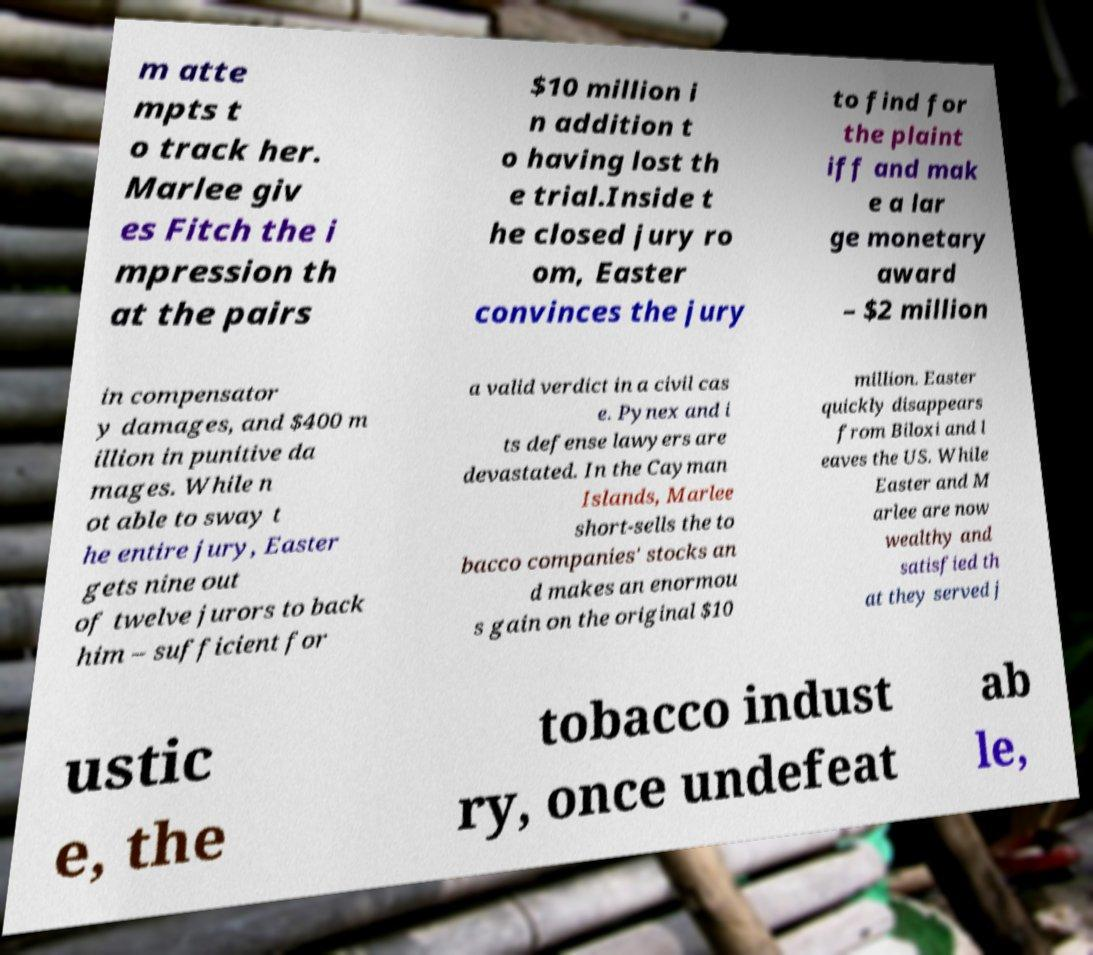For documentation purposes, I need the text within this image transcribed. Could you provide that? m atte mpts t o track her. Marlee giv es Fitch the i mpression th at the pairs $10 million i n addition t o having lost th e trial.Inside t he closed jury ro om, Easter convinces the jury to find for the plaint iff and mak e a lar ge monetary award – $2 million in compensator y damages, and $400 m illion in punitive da mages. While n ot able to sway t he entire jury, Easter gets nine out of twelve jurors to back him – sufficient for a valid verdict in a civil cas e. Pynex and i ts defense lawyers are devastated. In the Cayman Islands, Marlee short-sells the to bacco companies' stocks an d makes an enormou s gain on the original $10 million. Easter quickly disappears from Biloxi and l eaves the US. While Easter and M arlee are now wealthy and satisfied th at they served j ustic e, the tobacco indust ry, once undefeat ab le, 